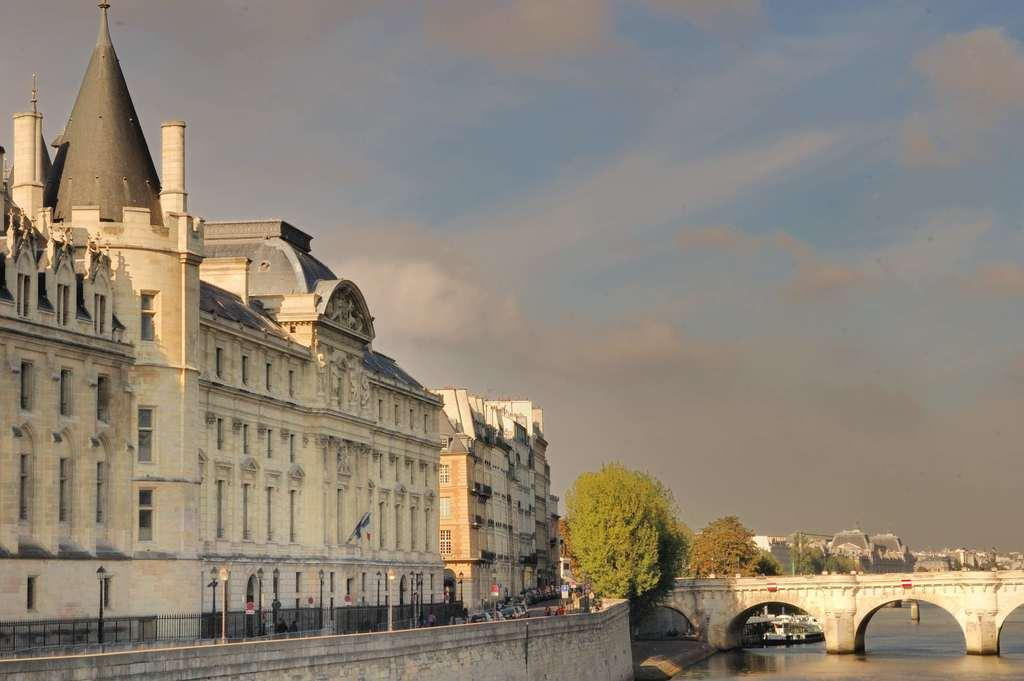What type of structures can be seen in the image? There are buildings in the image. What connects the two sides of the water in the image? There is a bridge in the image. What type of vegetation is present in the image? There are trees in the image. What can be seen flowing beneath the bridge in the image? There is water visible in the image. What is visible at the top of the image? The sky is visible at the top of the image. What type of leather is used to make the number visible in the image? There is no leather or number present in the image. How does the light affect the appearance of the buildings in the image? There is no mention of light in the provided facts, so we cannot determine its effect on the buildings in the image. 